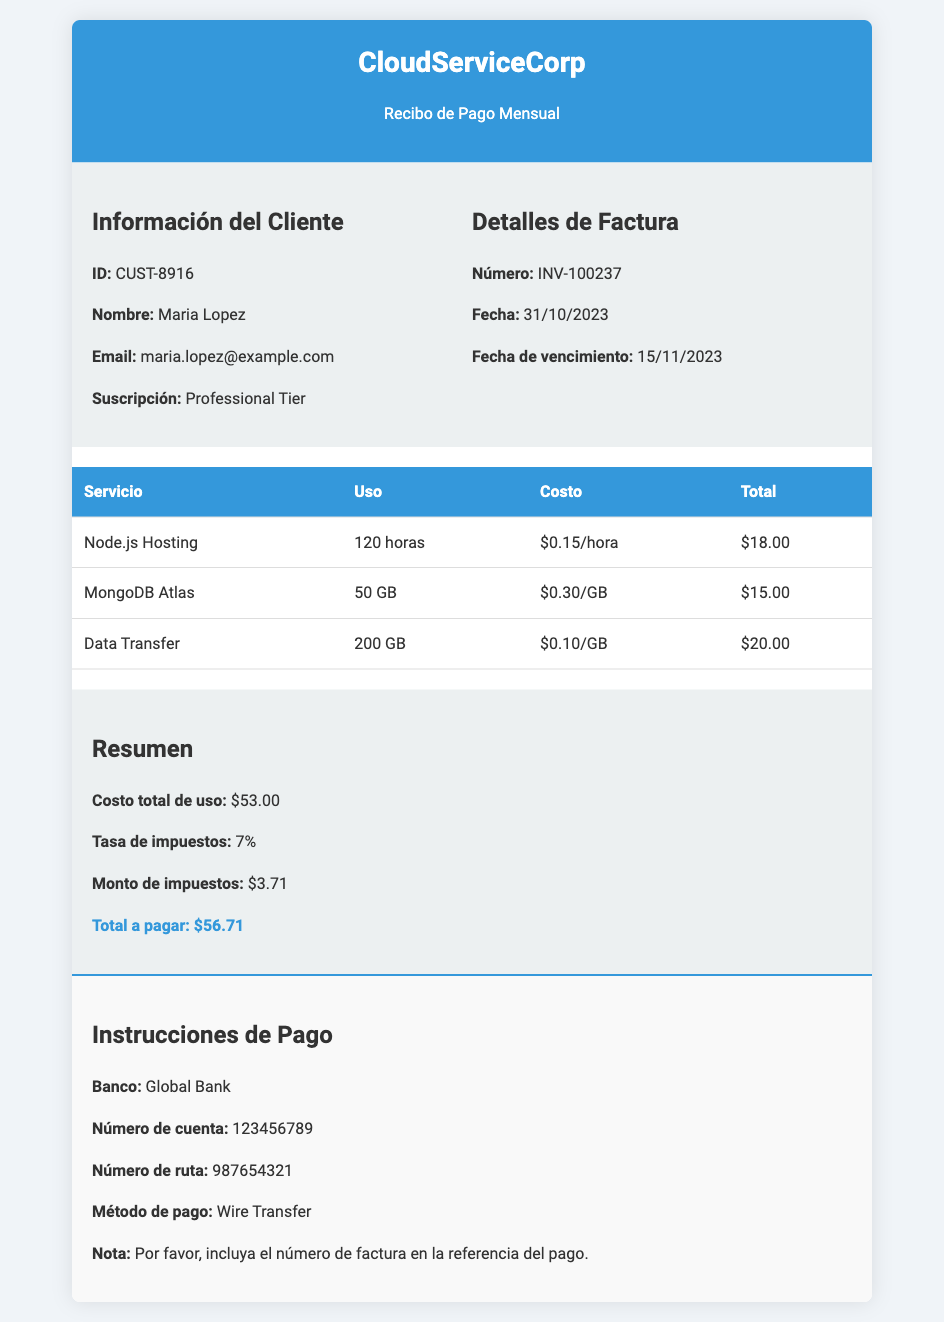¿Qué servicio tiene Maria Lopez? El documento menciona que su suscripción es de "Professional Tier".
Answer: Professional Tier ¿Cuánto se cobró por el hosting de Node.js? El uso de Node.js Hosting fue de 120 horas a una tarifa de $0.15/hora, lo que resulta en un total de $18.00.
Answer: $18.00 ¿Cuál es el número de la factura? El número de la factura está indicado como INV-100237 en el documento.
Answer: INV-100237 ¿Qué fecha es el vencimiento de esta factura? La fecha de vencimiento se establece para el 15 de noviembre de 2023.
Answer: 15/11/2023 ¿Cuál es el costo total de uso antes de impuestos? El costo total de uso se suma a $53.00 antes de impuestos.
Answer: $53.00 ¿Cuánto se cobra por Data Transfer? Se cobra $0.10 por GB de Data Transfer, y el uso fue de 200 GB, lo que suma $20.00.
Answer: $20.00 ¿Cuál es el monto total a pagar? El total a pagar, después de sumar los impuestos, es de $56.71.
Answer: $56.71 ¿Cuál es la tasa de impuestos aplicada? El documento menciona que la tasa de impuestos aplicada es del 7%.
Answer: 7% ¿A qué banco se debe realizar el pago? Se debe realizar el pago al "Global Bank".
Answer: Global Bank 